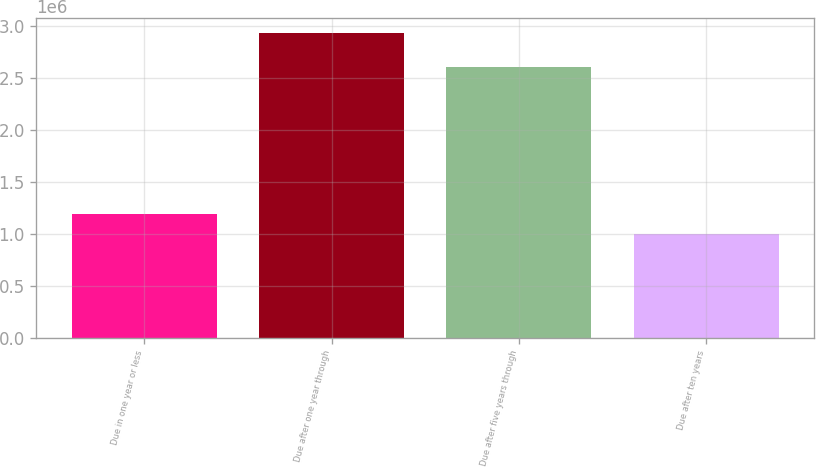Convert chart. <chart><loc_0><loc_0><loc_500><loc_500><bar_chart><fcel>Due in one year or less<fcel>Due after one year through<fcel>Due after five years through<fcel>Due after ten years<nl><fcel>1.18657e+06<fcel>2.93247e+06<fcel>2.60684e+06<fcel>992584<nl></chart> 